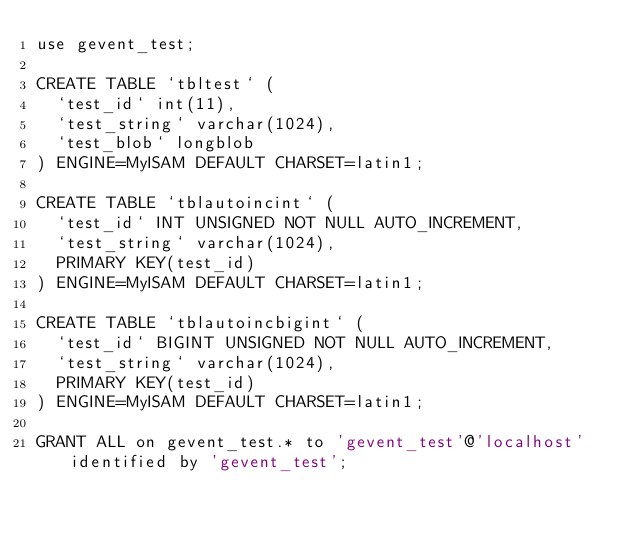<code> <loc_0><loc_0><loc_500><loc_500><_SQL_>use gevent_test;

CREATE TABLE `tbltest` (
  `test_id` int(11),
  `test_string` varchar(1024),
  `test_blob` longblob
) ENGINE=MyISAM DEFAULT CHARSET=latin1;

CREATE TABLE `tblautoincint` (
  `test_id` INT UNSIGNED NOT NULL AUTO_INCREMENT,
  `test_string` varchar(1024),
  PRIMARY KEY(test_id)
) ENGINE=MyISAM DEFAULT CHARSET=latin1;

CREATE TABLE `tblautoincbigint` (
  `test_id` BIGINT UNSIGNED NOT NULL AUTO_INCREMENT,
  `test_string` varchar(1024),
  PRIMARY KEY(test_id)  
) ENGINE=MyISAM DEFAULT CHARSET=latin1;

GRANT ALL on gevent_test.* to 'gevent_test'@'localhost' identified by 'gevent_test';
</code> 